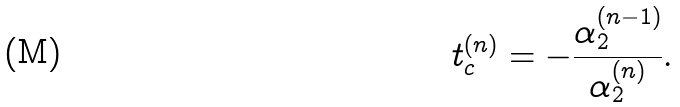Convert formula to latex. <formula><loc_0><loc_0><loc_500><loc_500>t _ { c } ^ { ( n ) } = - \frac { \alpha _ { 2 } ^ { ( n - 1 ) } } { \alpha _ { 2 } ^ { ( n ) } } .</formula> 